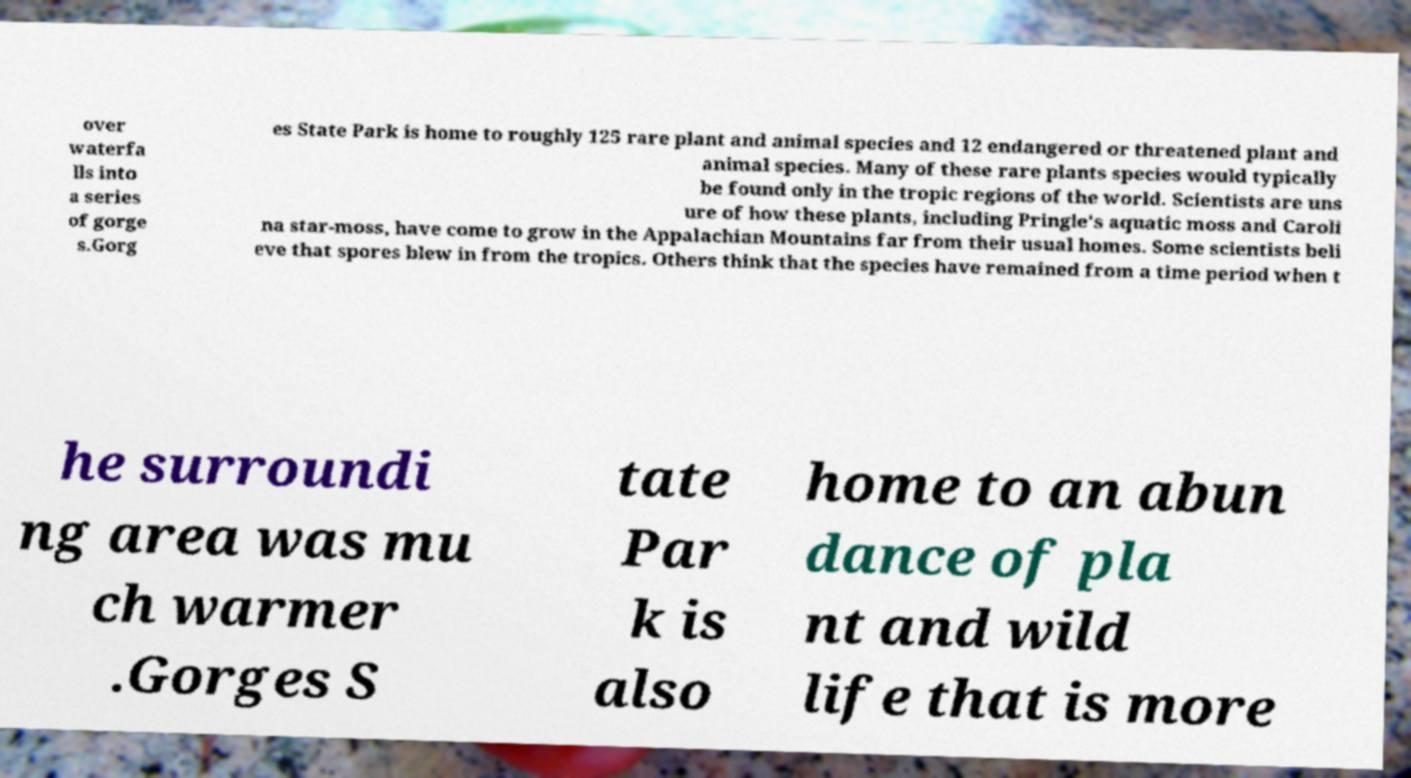Please read and relay the text visible in this image. What does it say? over waterfa lls into a series of gorge s.Gorg es State Park is home to roughly 125 rare plant and animal species and 12 endangered or threatened plant and animal species. Many of these rare plants species would typically be found only in the tropic regions of the world. Scientists are uns ure of how these plants, including Pringle's aquatic moss and Caroli na star-moss, have come to grow in the Appalachian Mountains far from their usual homes. Some scientists beli eve that spores blew in from the tropics. Others think that the species have remained from a time period when t he surroundi ng area was mu ch warmer .Gorges S tate Par k is also home to an abun dance of pla nt and wild life that is more 